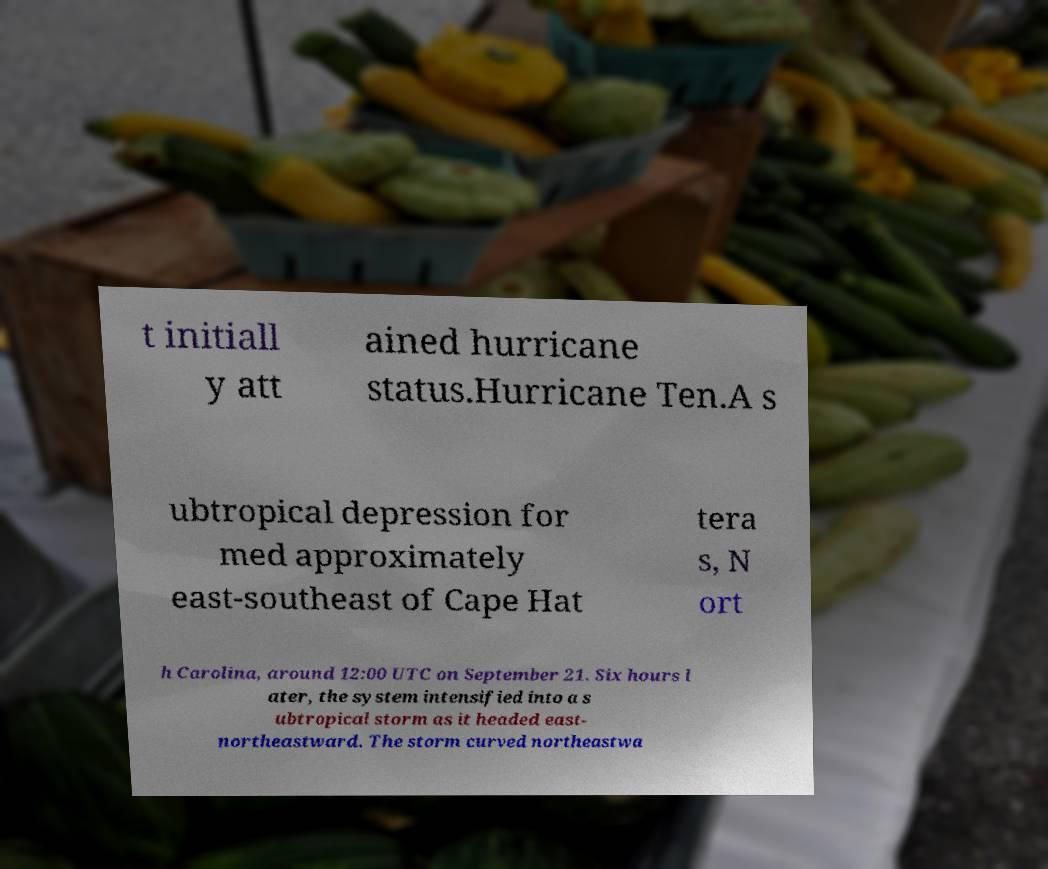Please identify and transcribe the text found in this image. t initiall y att ained hurricane status.Hurricane Ten.A s ubtropical depression for med approximately east-southeast of Cape Hat tera s, N ort h Carolina, around 12:00 UTC on September 21. Six hours l ater, the system intensified into a s ubtropical storm as it headed east- northeastward. The storm curved northeastwa 